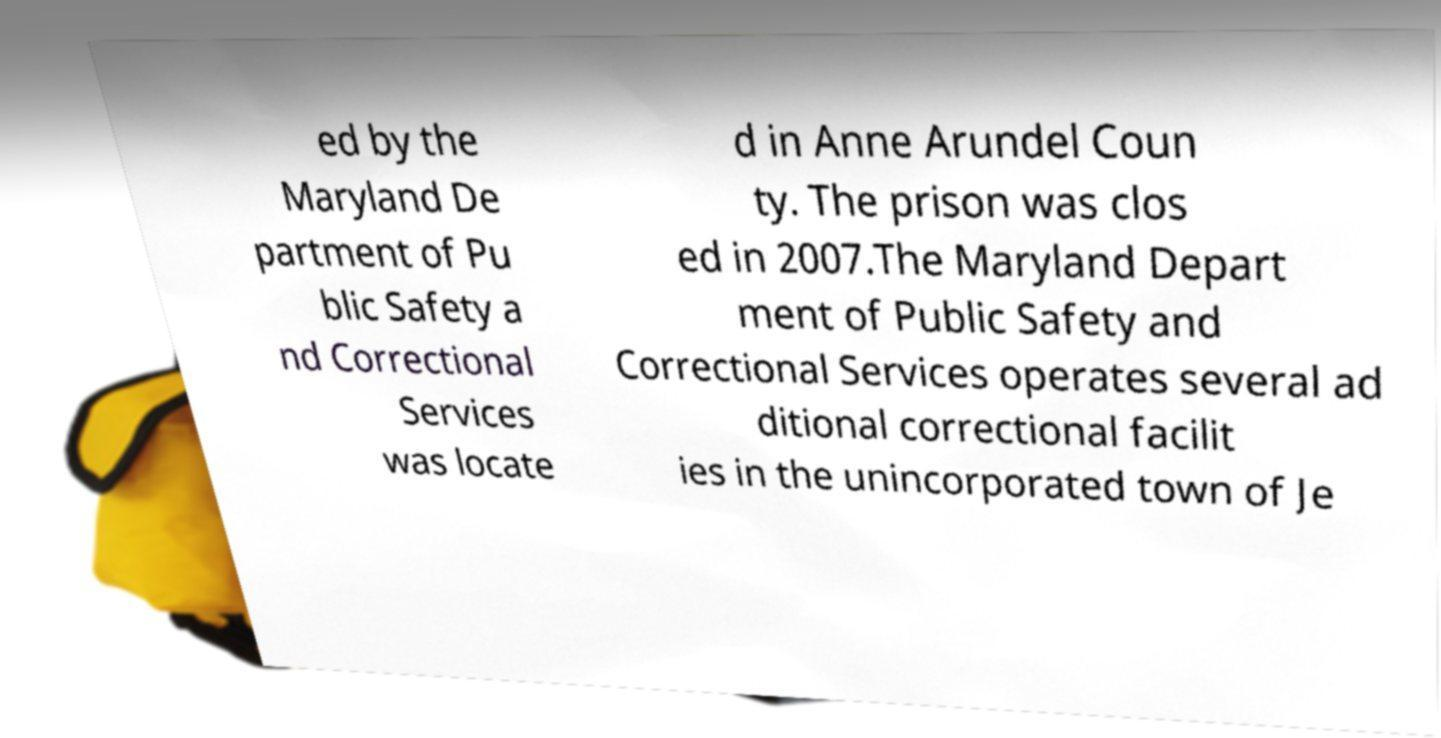Can you read and provide the text displayed in the image?This photo seems to have some interesting text. Can you extract and type it out for me? ed by the Maryland De partment of Pu blic Safety a nd Correctional Services was locate d in Anne Arundel Coun ty. The prison was clos ed in 2007.The Maryland Depart ment of Public Safety and Correctional Services operates several ad ditional correctional facilit ies in the unincorporated town of Je 